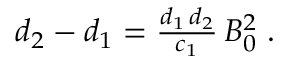Convert formula to latex. <formula><loc_0><loc_0><loc_500><loc_500>\begin{array} { r } { d _ { 2 } - d _ { 1 } = \frac { d _ { 1 } \, d _ { 2 } } { c _ { 1 } } \, B _ { 0 } ^ { 2 } \, . } \end{array}</formula> 